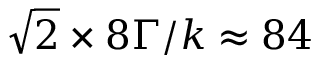Convert formula to latex. <formula><loc_0><loc_0><loc_500><loc_500>\sqrt { 2 } \times 8 \Gamma / k \approx 8 4</formula> 